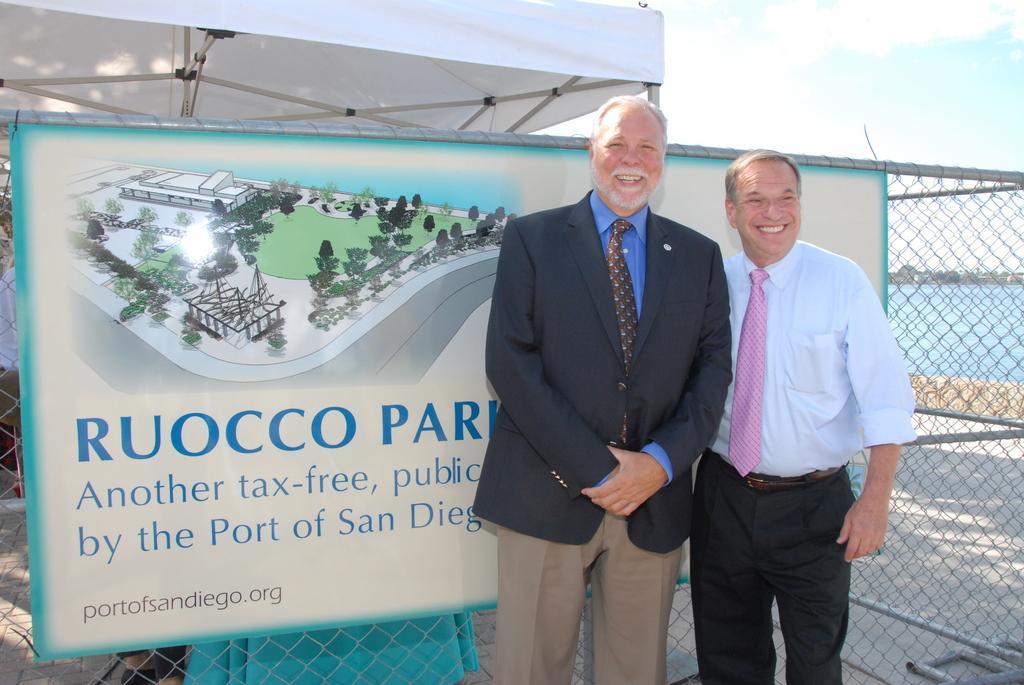Can you describe this image briefly? There are two men and they are smiling. In the background we can see a banner, fence, water, and sky. 